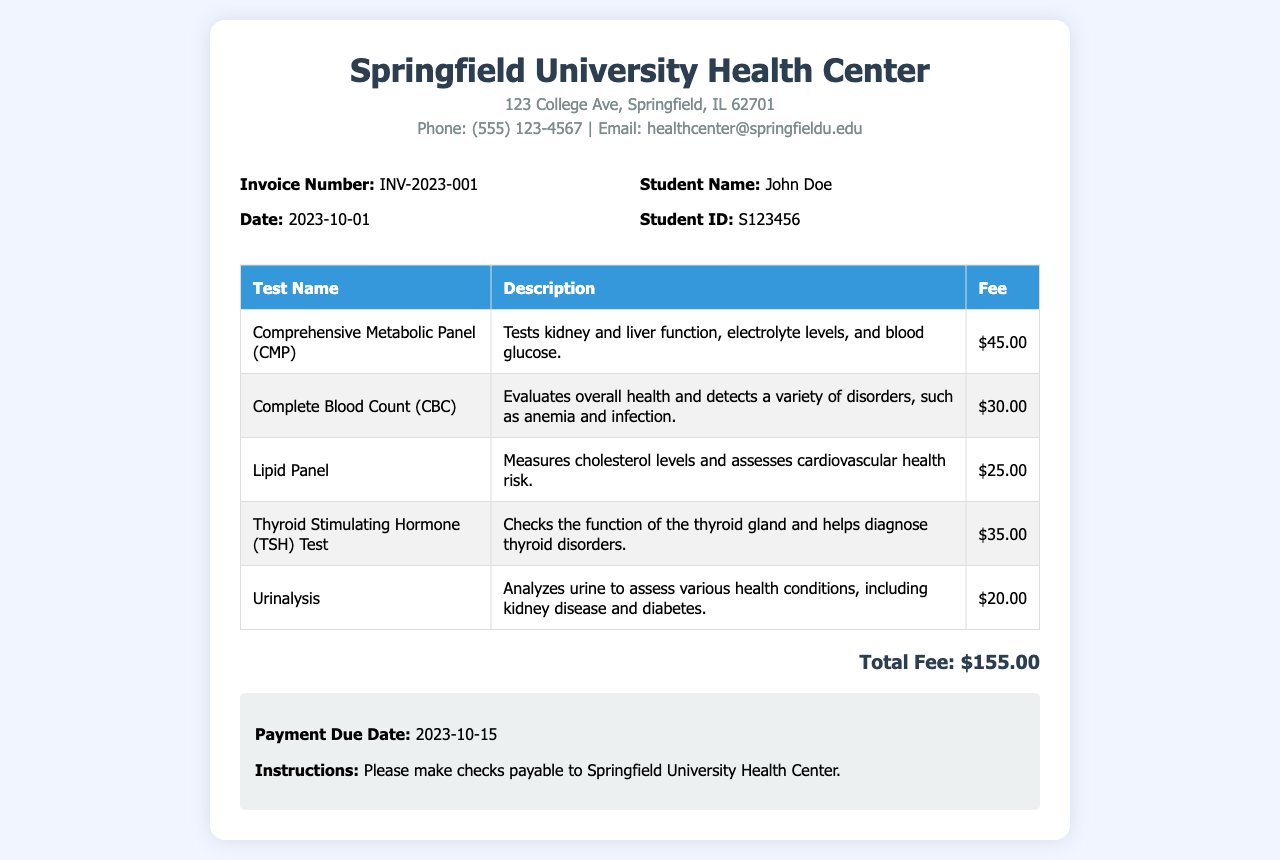What is the invoice number? The invoice number is stated in the invoice details section.
Answer: INV-2023-001 What is the total fee for the health screening services? The total fee is clearly listed at the end of the invoice.
Answer: $155.00 Who is the student listed on the invoice? The student's name appears in the invoice details section.
Answer: John Doe What is the fee for the Comprehensive Metabolic Panel test? The fee for this test is provided in the table of tests.
Answer: $45.00 What is the payment due date? The payment due date is mentioned in the instructions section.
Answer: 2023-10-15 How many tests are listed in the invoice? The number of tests is counted from the rows in the table.
Answer: 5 What is the description of the Lipid Panel test? The description of the Lipid Panel is included in the table.
Answer: Measures cholesterol levels and assesses cardiovascular health risk What does the Complete Blood Count (CBC) test evaluate? The evaluation purpose of the CBC is specified in its description.
Answer: Overall health and detects a variety of disorders, such as anemia and infection 